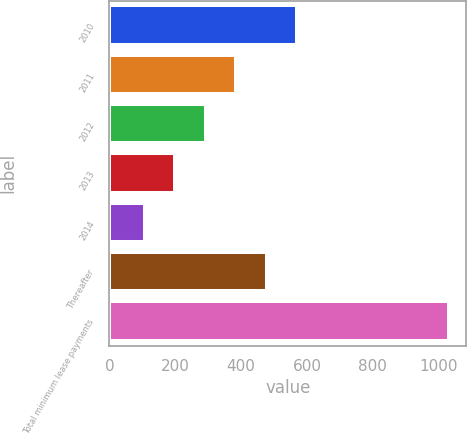<chart> <loc_0><loc_0><loc_500><loc_500><bar_chart><fcel>2010<fcel>2011<fcel>2012<fcel>2013<fcel>2014<fcel>Thereafter<fcel>Total minimum lease payments<nl><fcel>570.5<fcel>385.5<fcel>293<fcel>200.5<fcel>108<fcel>478<fcel>1033<nl></chart> 